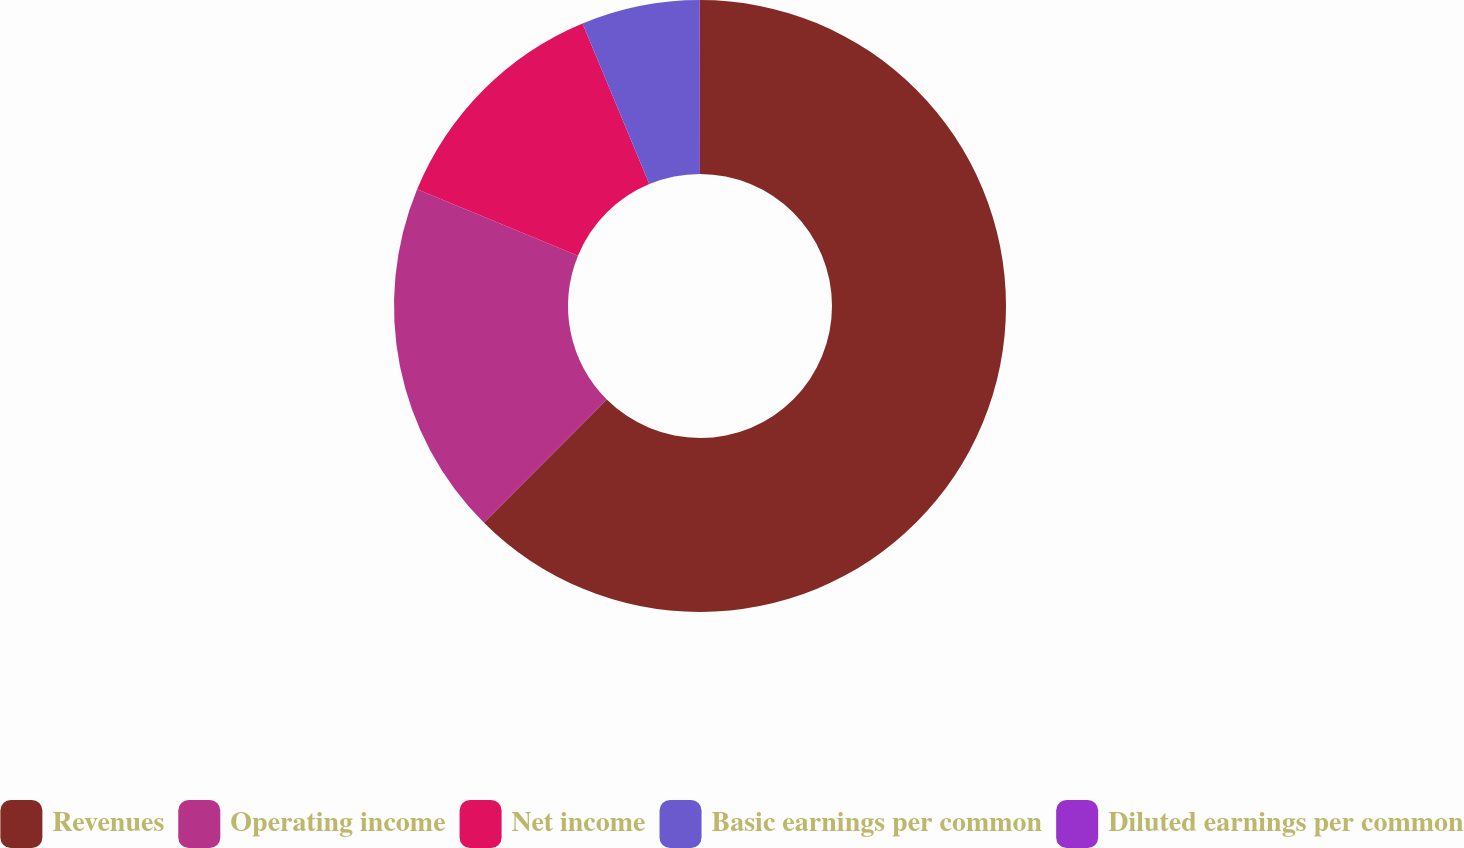Convert chart to OTSL. <chart><loc_0><loc_0><loc_500><loc_500><pie_chart><fcel>Revenues<fcel>Operating income<fcel>Net income<fcel>Basic earnings per common<fcel>Diluted earnings per common<nl><fcel>62.47%<fcel>18.75%<fcel>12.5%<fcel>6.26%<fcel>0.01%<nl></chart> 